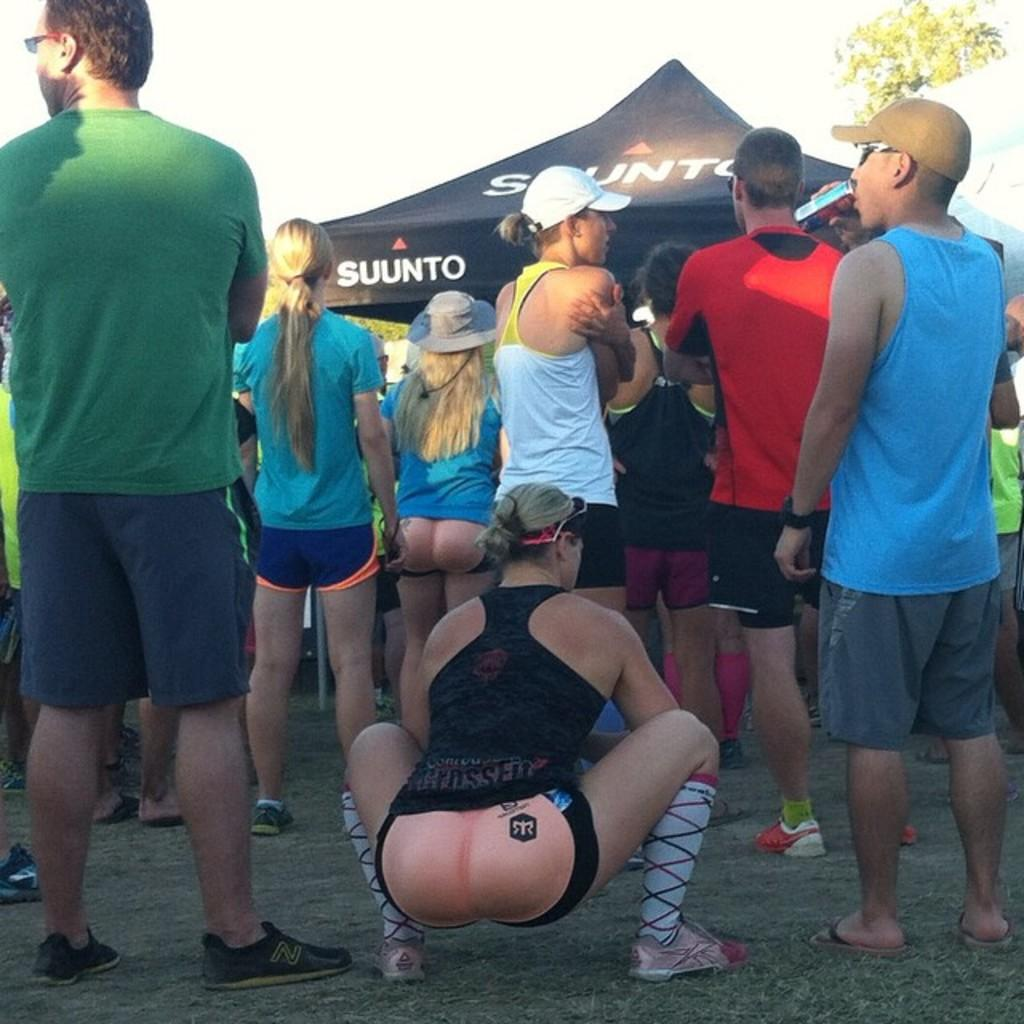Provide a one-sentence caption for the provided image. A tent with the word SUUNTO can be seen behind a crowd of people. 